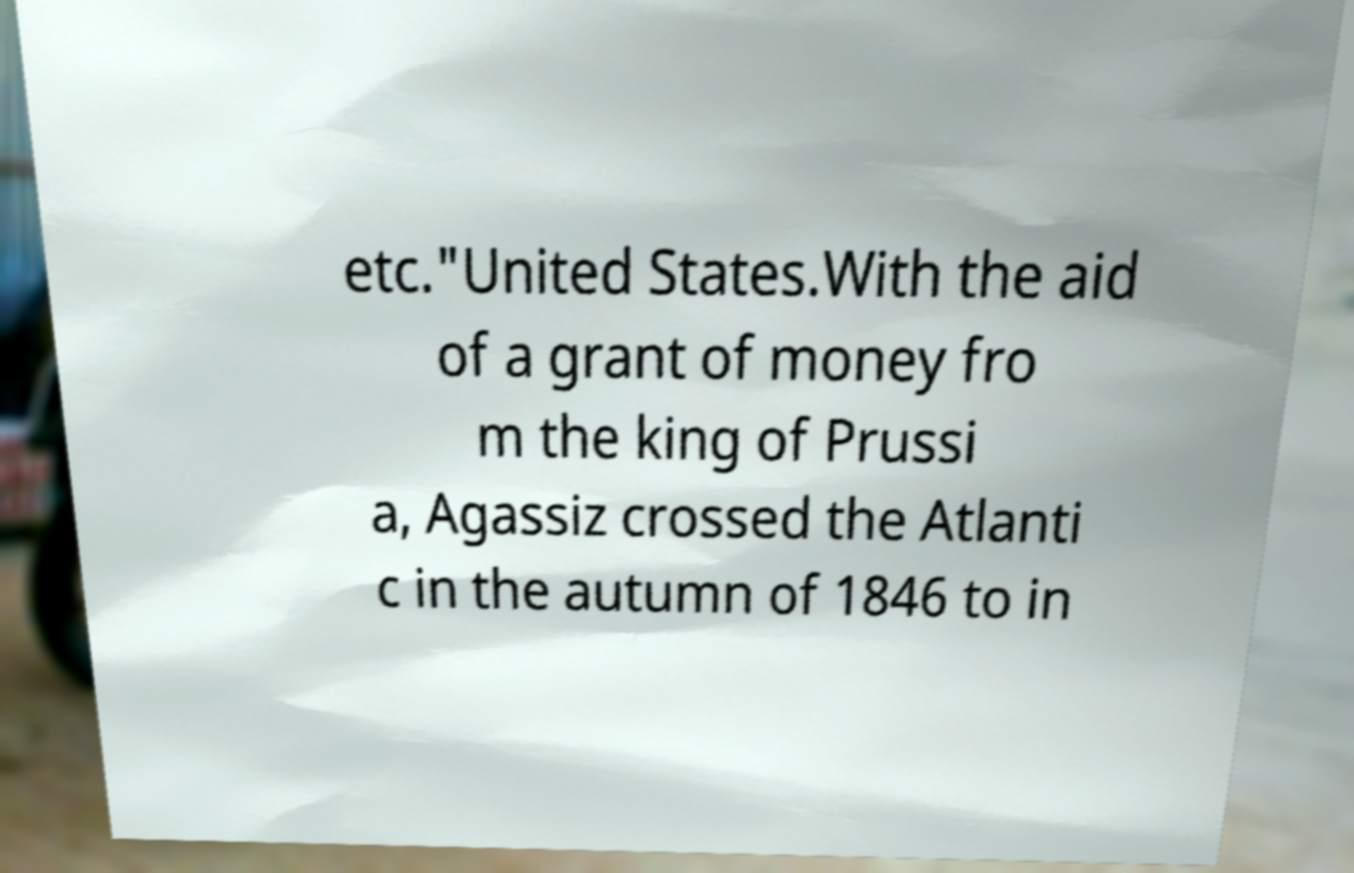Can you accurately transcribe the text from the provided image for me? etc."United States.With the aid of a grant of money fro m the king of Prussi a, Agassiz crossed the Atlanti c in the autumn of 1846 to in 